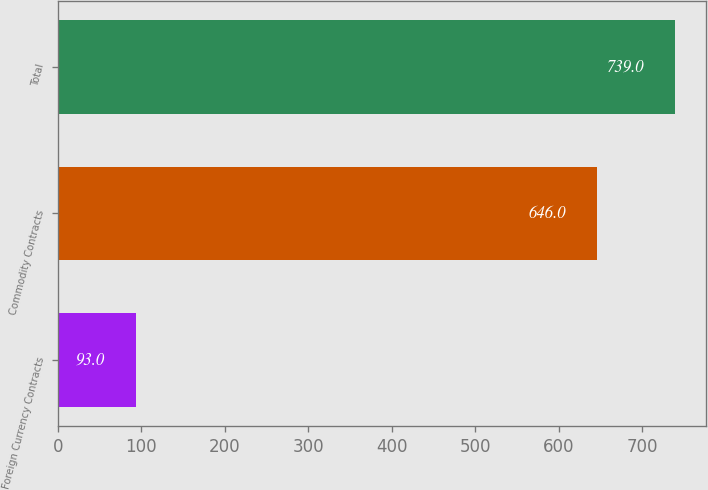Convert chart to OTSL. <chart><loc_0><loc_0><loc_500><loc_500><bar_chart><fcel>Foreign Currency Contracts<fcel>Commodity Contracts<fcel>Total<nl><fcel>93<fcel>646<fcel>739<nl></chart> 